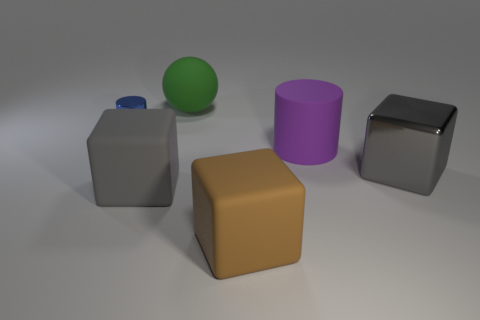Are there any green objects of the same shape as the big purple object?
Give a very brief answer. No. There is a big thing to the right of the big purple cylinder; does it have the same shape as the big rubber object behind the blue object?
Give a very brief answer. No. There is a cylinder that is the same size as the brown cube; what is it made of?
Your answer should be compact. Rubber. What number of other objects are there of the same material as the big green thing?
Your response must be concise. 3. What shape is the big gray object that is behind the block that is left of the big green object?
Provide a short and direct response. Cube. How many things are brown rubber cubes or large cubes that are in front of the large metallic block?
Make the answer very short. 2. How many other objects are there of the same color as the large rubber cylinder?
Offer a very short reply. 0. What number of cyan objects are big blocks or matte cylinders?
Provide a short and direct response. 0. Is there a small blue shiny cylinder in front of the large gray rubber block left of the rubber object that is behind the tiny thing?
Your response must be concise. No. Is there any other thing that is the same size as the brown object?
Keep it short and to the point. Yes. 